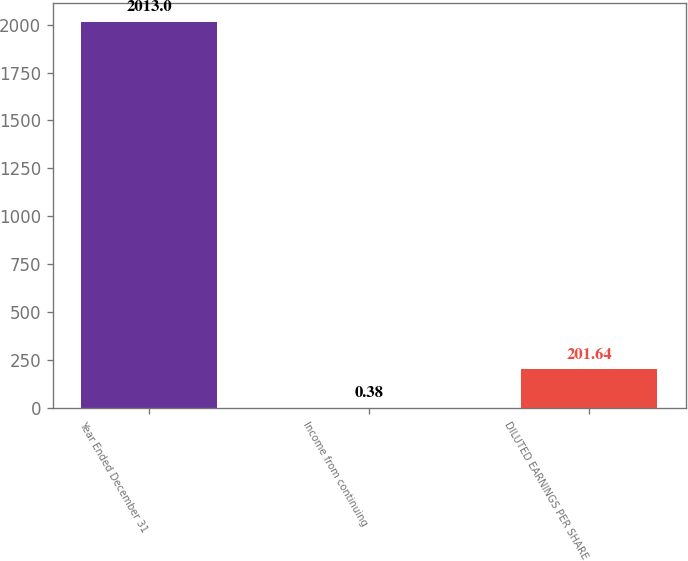<chart> <loc_0><loc_0><loc_500><loc_500><bar_chart><fcel>Year Ended December 31<fcel>Income from continuing<fcel>DILUTED EARNINGS PER SHARE<nl><fcel>2013<fcel>0.38<fcel>201.64<nl></chart> 